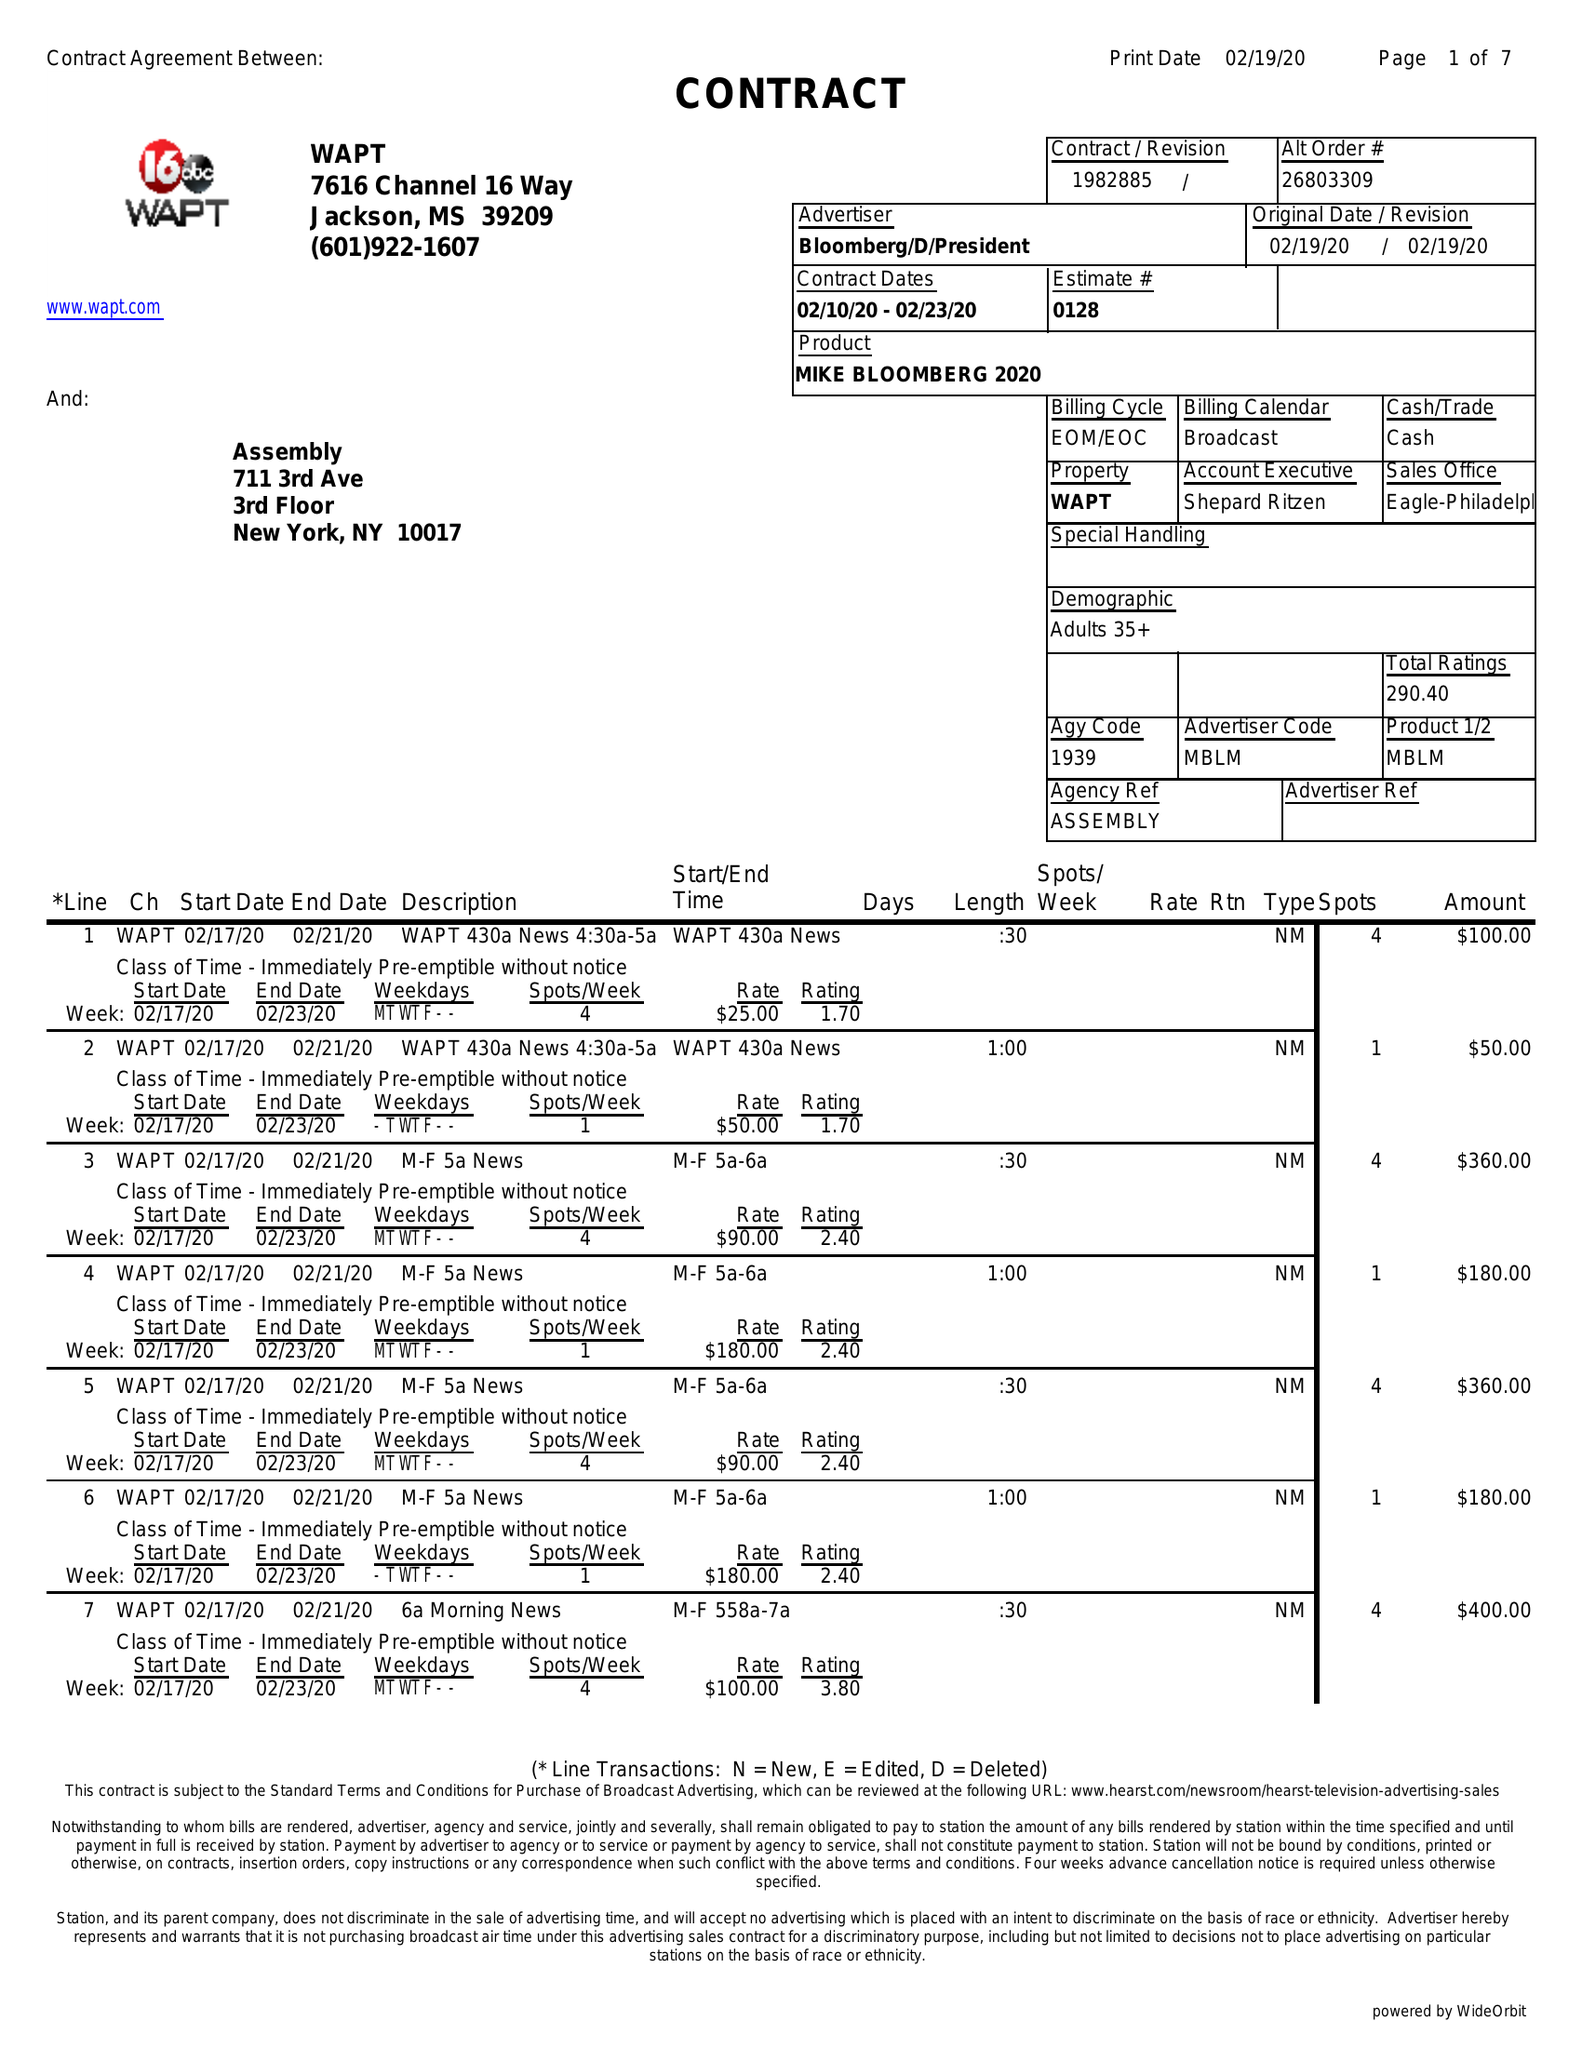What is the value for the contract_num?
Answer the question using a single word or phrase. 1982885 